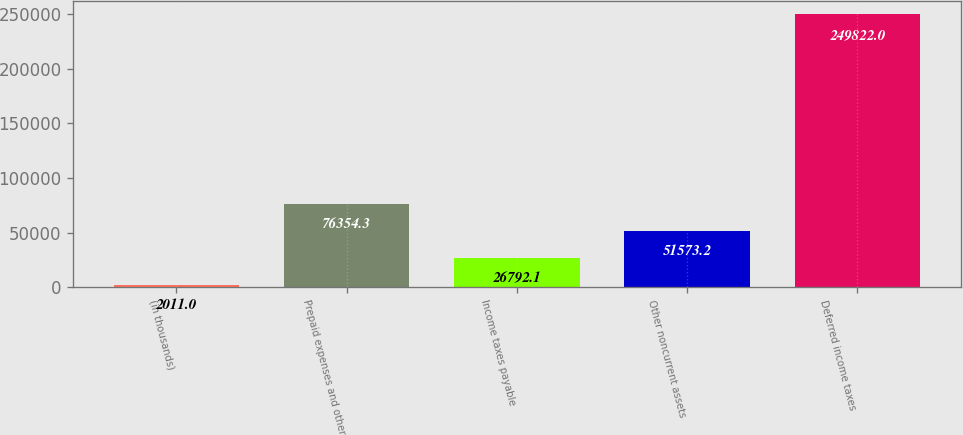Convert chart. <chart><loc_0><loc_0><loc_500><loc_500><bar_chart><fcel>(in thousands)<fcel>Prepaid expenses and other<fcel>Income taxes payable<fcel>Other noncurrent assets<fcel>Deferred income taxes<nl><fcel>2011<fcel>76354.3<fcel>26792.1<fcel>51573.2<fcel>249822<nl></chart> 